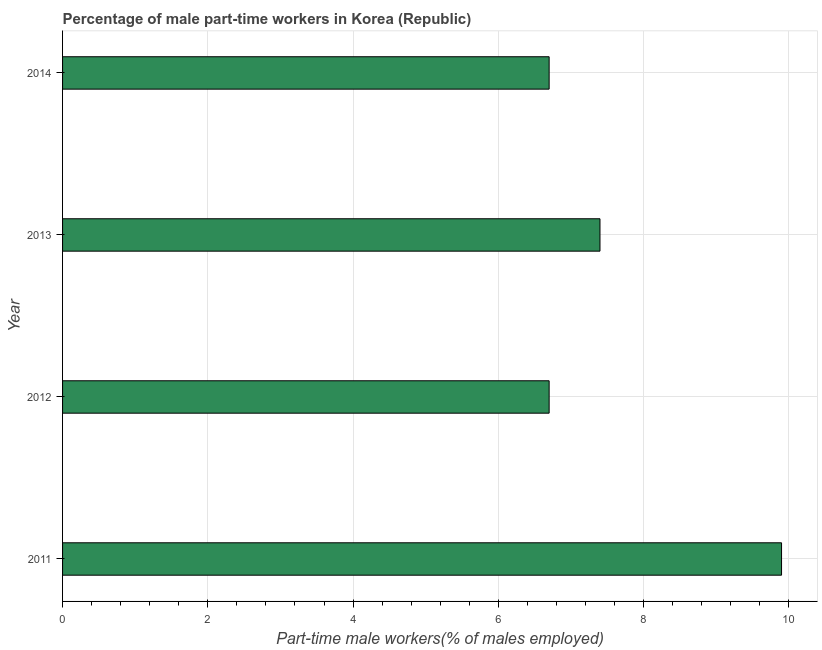Does the graph contain any zero values?
Your answer should be compact. No. Does the graph contain grids?
Ensure brevity in your answer.  Yes. What is the title of the graph?
Make the answer very short. Percentage of male part-time workers in Korea (Republic). What is the label or title of the X-axis?
Your answer should be compact. Part-time male workers(% of males employed). What is the label or title of the Y-axis?
Give a very brief answer. Year. What is the percentage of part-time male workers in 2011?
Your response must be concise. 9.9. Across all years, what is the maximum percentage of part-time male workers?
Keep it short and to the point. 9.9. Across all years, what is the minimum percentage of part-time male workers?
Keep it short and to the point. 6.7. In which year was the percentage of part-time male workers maximum?
Offer a very short reply. 2011. In which year was the percentage of part-time male workers minimum?
Offer a terse response. 2012. What is the sum of the percentage of part-time male workers?
Ensure brevity in your answer.  30.7. What is the average percentage of part-time male workers per year?
Make the answer very short. 7.67. What is the median percentage of part-time male workers?
Your answer should be compact. 7.05. What is the ratio of the percentage of part-time male workers in 2013 to that in 2014?
Offer a terse response. 1.1. Is the percentage of part-time male workers in 2011 less than that in 2012?
Provide a short and direct response. No. What is the difference between the highest and the lowest percentage of part-time male workers?
Offer a very short reply. 3.2. In how many years, is the percentage of part-time male workers greater than the average percentage of part-time male workers taken over all years?
Keep it short and to the point. 1. How many bars are there?
Provide a succinct answer. 4. What is the difference between two consecutive major ticks on the X-axis?
Give a very brief answer. 2. What is the Part-time male workers(% of males employed) of 2011?
Your answer should be very brief. 9.9. What is the Part-time male workers(% of males employed) of 2012?
Provide a succinct answer. 6.7. What is the Part-time male workers(% of males employed) in 2013?
Offer a very short reply. 7.4. What is the Part-time male workers(% of males employed) in 2014?
Your response must be concise. 6.7. What is the difference between the Part-time male workers(% of males employed) in 2011 and 2013?
Keep it short and to the point. 2.5. What is the difference between the Part-time male workers(% of males employed) in 2011 and 2014?
Offer a very short reply. 3.2. What is the difference between the Part-time male workers(% of males employed) in 2012 and 2014?
Provide a short and direct response. 0. What is the difference between the Part-time male workers(% of males employed) in 2013 and 2014?
Give a very brief answer. 0.7. What is the ratio of the Part-time male workers(% of males employed) in 2011 to that in 2012?
Make the answer very short. 1.48. What is the ratio of the Part-time male workers(% of males employed) in 2011 to that in 2013?
Keep it short and to the point. 1.34. What is the ratio of the Part-time male workers(% of males employed) in 2011 to that in 2014?
Give a very brief answer. 1.48. What is the ratio of the Part-time male workers(% of males employed) in 2012 to that in 2013?
Your answer should be compact. 0.91. What is the ratio of the Part-time male workers(% of males employed) in 2013 to that in 2014?
Ensure brevity in your answer.  1.1. 